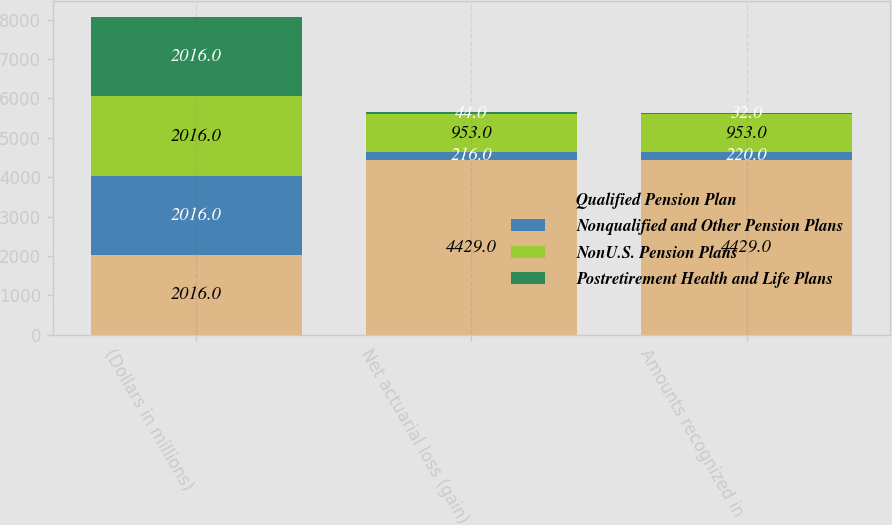Convert chart. <chart><loc_0><loc_0><loc_500><loc_500><stacked_bar_chart><ecel><fcel>(Dollars in millions)<fcel>Net actuarial loss (gain)<fcel>Amounts recognized in<nl><fcel>Qualified Pension Plan<fcel>2016<fcel>4429<fcel>4429<nl><fcel>Nonqualified and Other Pension Plans<fcel>2016<fcel>216<fcel>220<nl><fcel>NonU.S. Pension Plans<fcel>2016<fcel>953<fcel>953<nl><fcel>Postretirement Health and Life Plans<fcel>2016<fcel>44<fcel>32<nl></chart> 